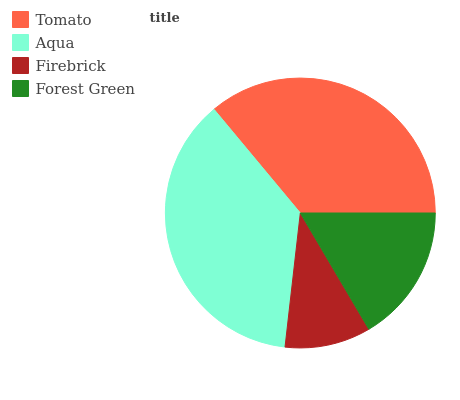Is Firebrick the minimum?
Answer yes or no. Yes. Is Aqua the maximum?
Answer yes or no. Yes. Is Aqua the minimum?
Answer yes or no. No. Is Firebrick the maximum?
Answer yes or no. No. Is Aqua greater than Firebrick?
Answer yes or no. Yes. Is Firebrick less than Aqua?
Answer yes or no. Yes. Is Firebrick greater than Aqua?
Answer yes or no. No. Is Aqua less than Firebrick?
Answer yes or no. No. Is Tomato the high median?
Answer yes or no. Yes. Is Forest Green the low median?
Answer yes or no. Yes. Is Forest Green the high median?
Answer yes or no. No. Is Aqua the low median?
Answer yes or no. No. 